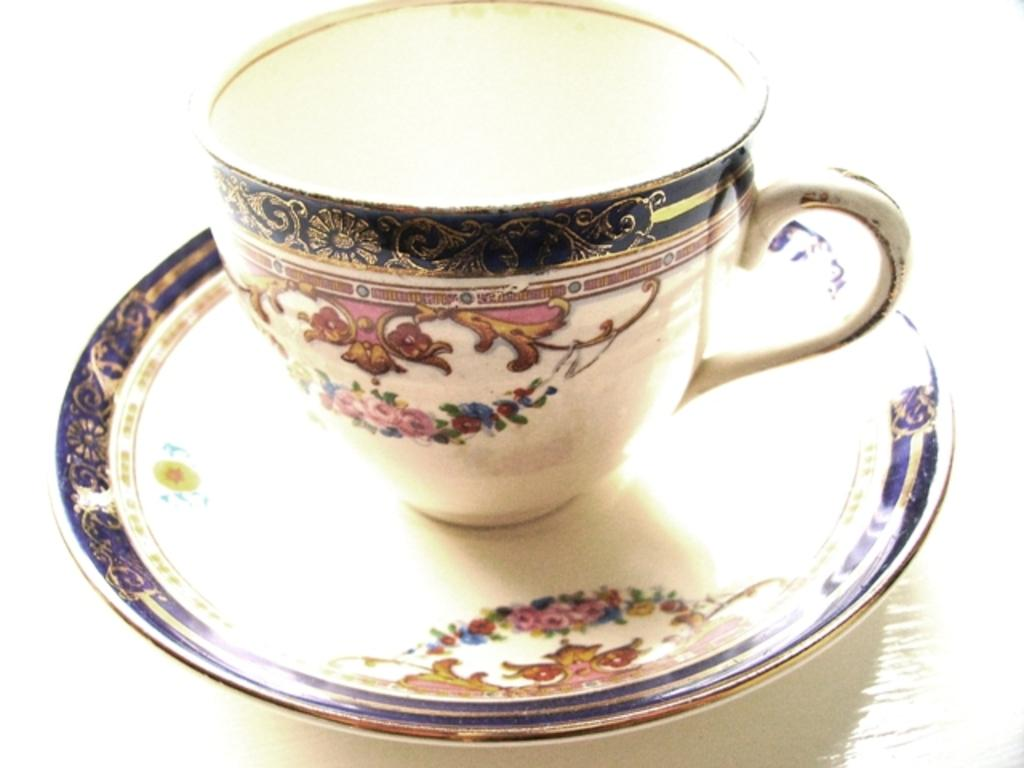What is present in the image that can hold liquids? There is a cup in the image that can hold liquids. How is the cup positioned in the image? The cup is placed on a saucer in the image. What can be observed about the appearance of the cup and saucer? The cup and saucer have designs. What type of competition is the doll participating in within the image? There is no doll present in the image, so there is no competition involving a doll. 